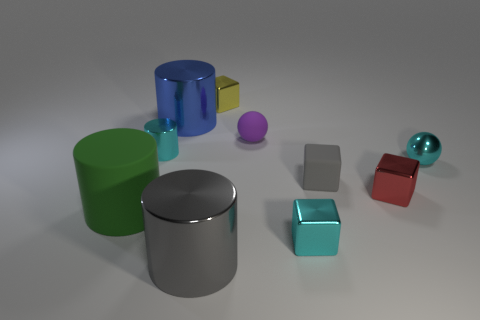The metallic cylinder that is the same color as the rubber block is what size?
Provide a short and direct response. Large. There is a tiny yellow object that is the same material as the blue cylinder; what shape is it?
Your answer should be compact. Cube. What shape is the object that is the same color as the small matte block?
Keep it short and to the point. Cylinder. There is another matte thing that is the same size as the purple rubber thing; what shape is it?
Keep it short and to the point. Cube. Is there a small rubber block of the same color as the big matte cylinder?
Ensure brevity in your answer.  No. How big is the blue metallic cylinder?
Ensure brevity in your answer.  Large. Does the purple sphere have the same material as the large green thing?
Your answer should be compact. Yes. What number of cyan metallic objects are behind the thing that is left of the small metal thing to the left of the yellow metal block?
Offer a terse response. 2. There is a gray rubber object on the right side of the small yellow metallic cube; what shape is it?
Give a very brief answer. Cube. How many other objects are the same material as the large blue thing?
Offer a very short reply. 6. 